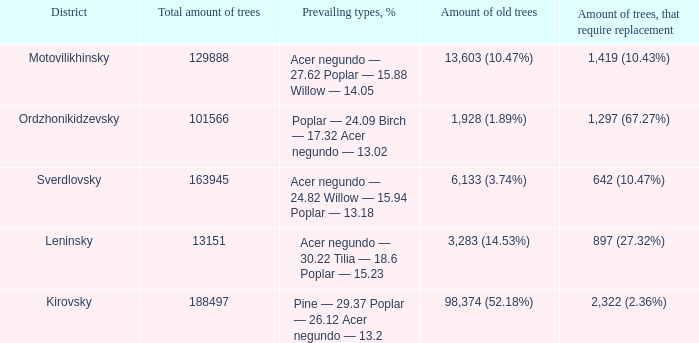What is the amount of trees, that require replacement when prevailing types, % is pine — 29.37 poplar — 26.12 acer negundo — 13.2? 2,322 (2.36%). 